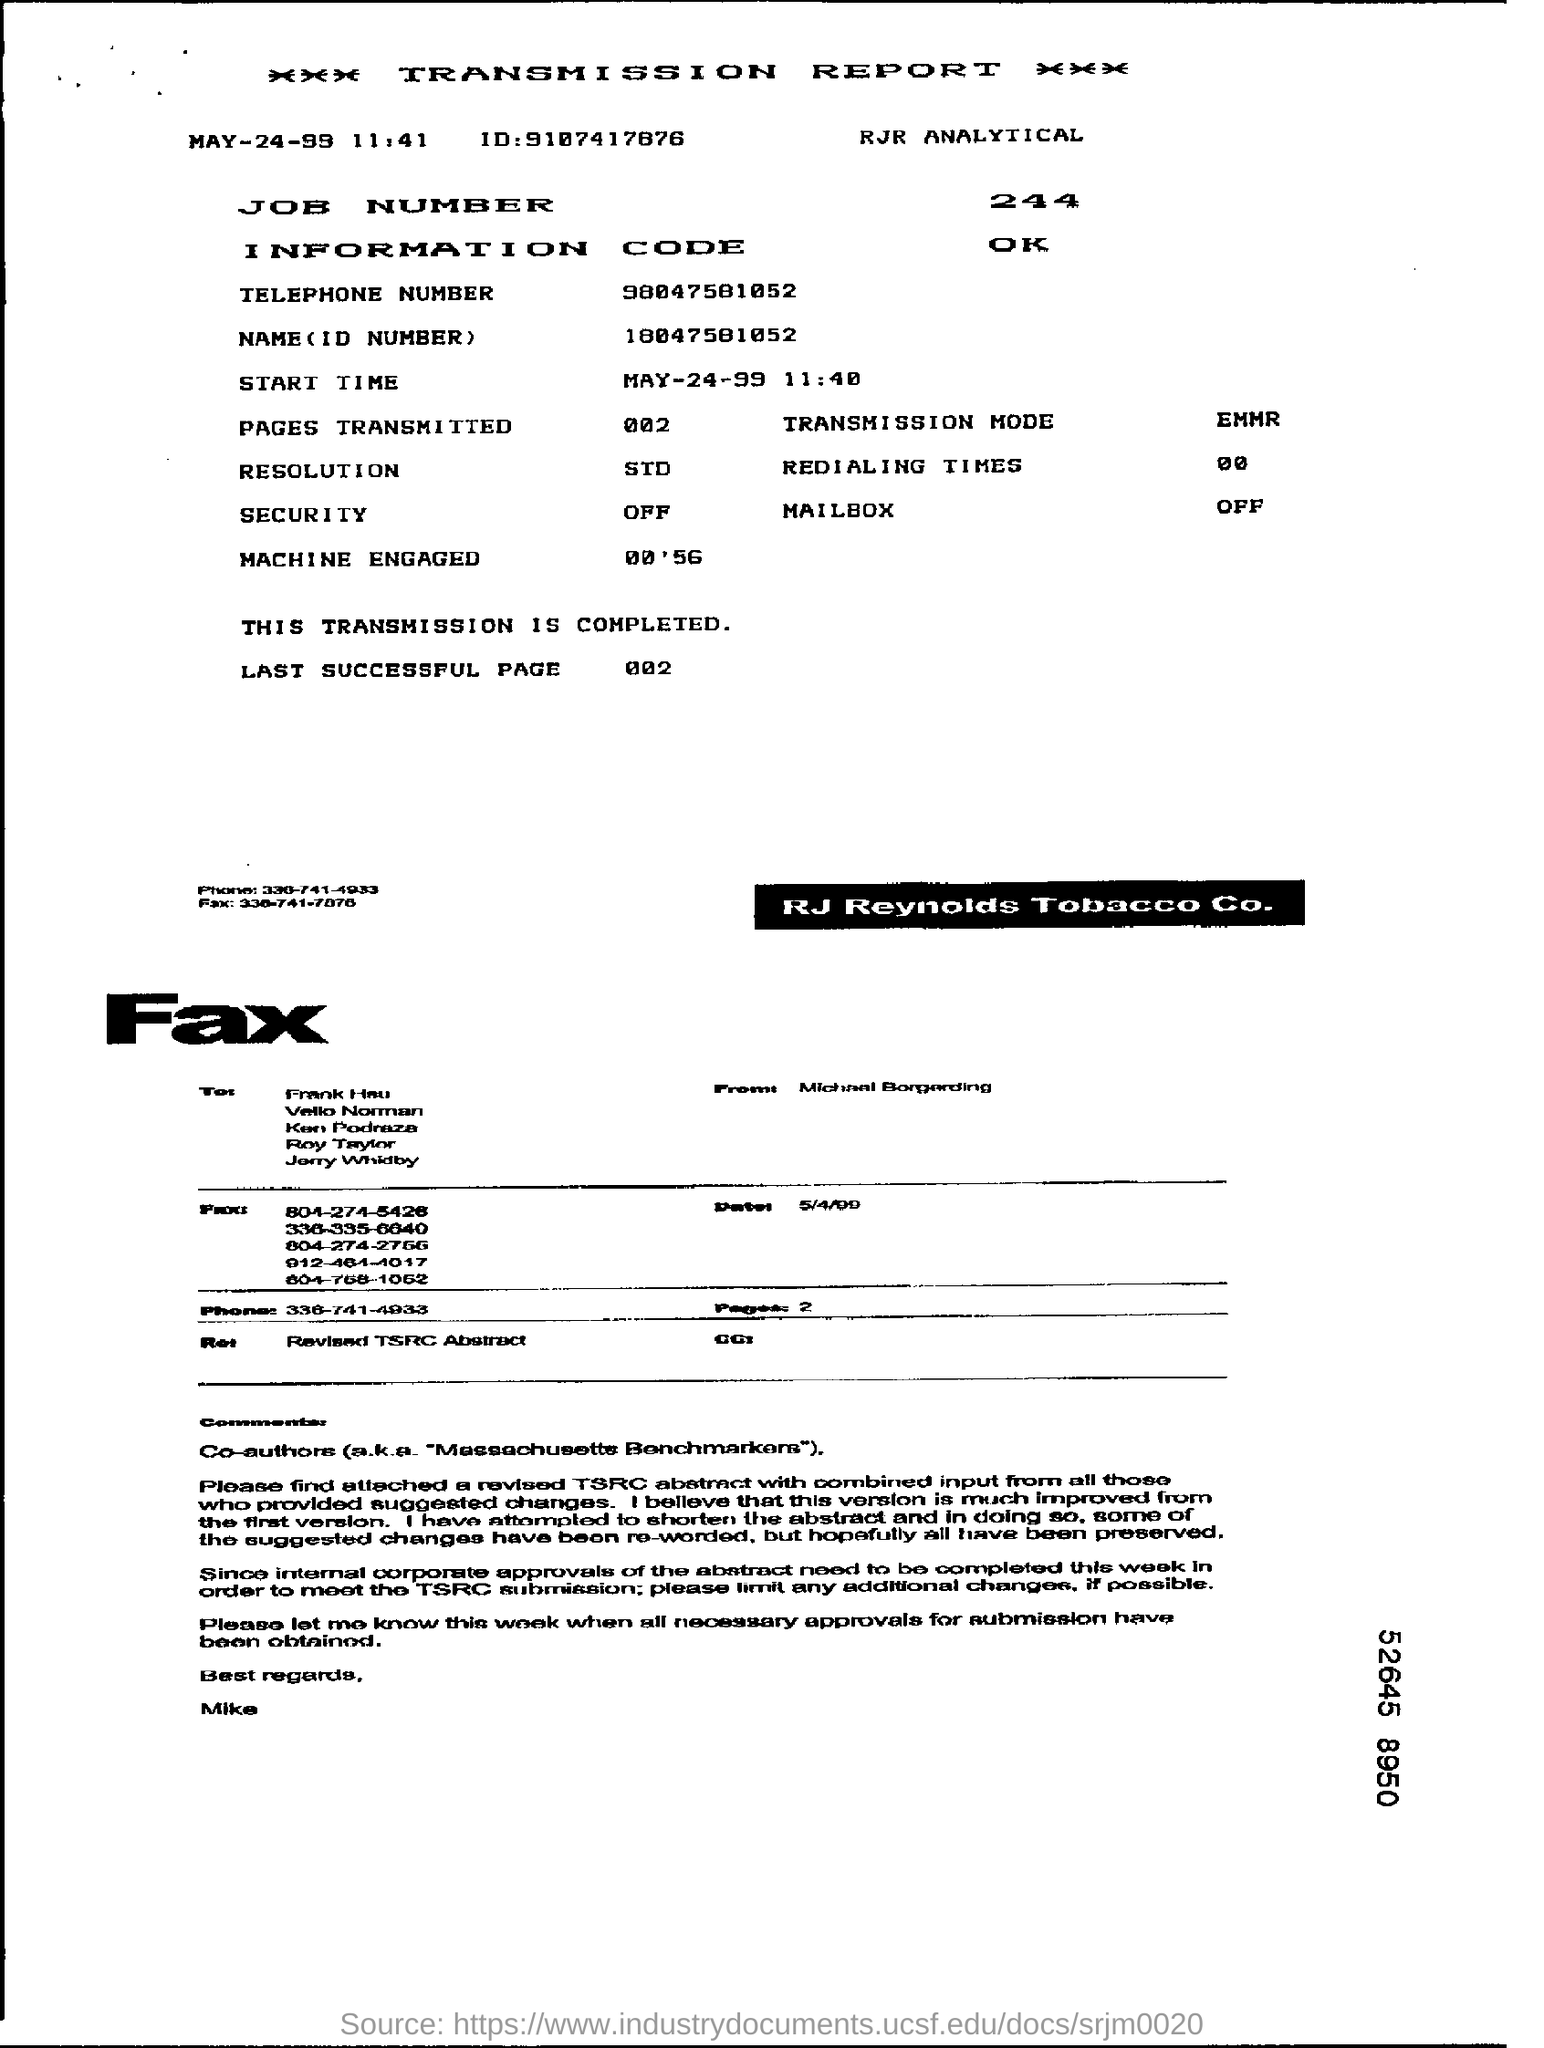What kind of report is given here?
Make the answer very short. TRANSMISSION REPORT. How many pages are transmitted as per the document?
Give a very brief answer. 002. What is the Information code given?
Provide a succinct answer. OK. What is the start time of the transmission?
Offer a terse response. MAY-24-99  11:40. What is the Job Number mentioned in the document?
Ensure brevity in your answer.  244. What is the Name(ID Number) given?
Provide a short and direct response. 18047581052. 